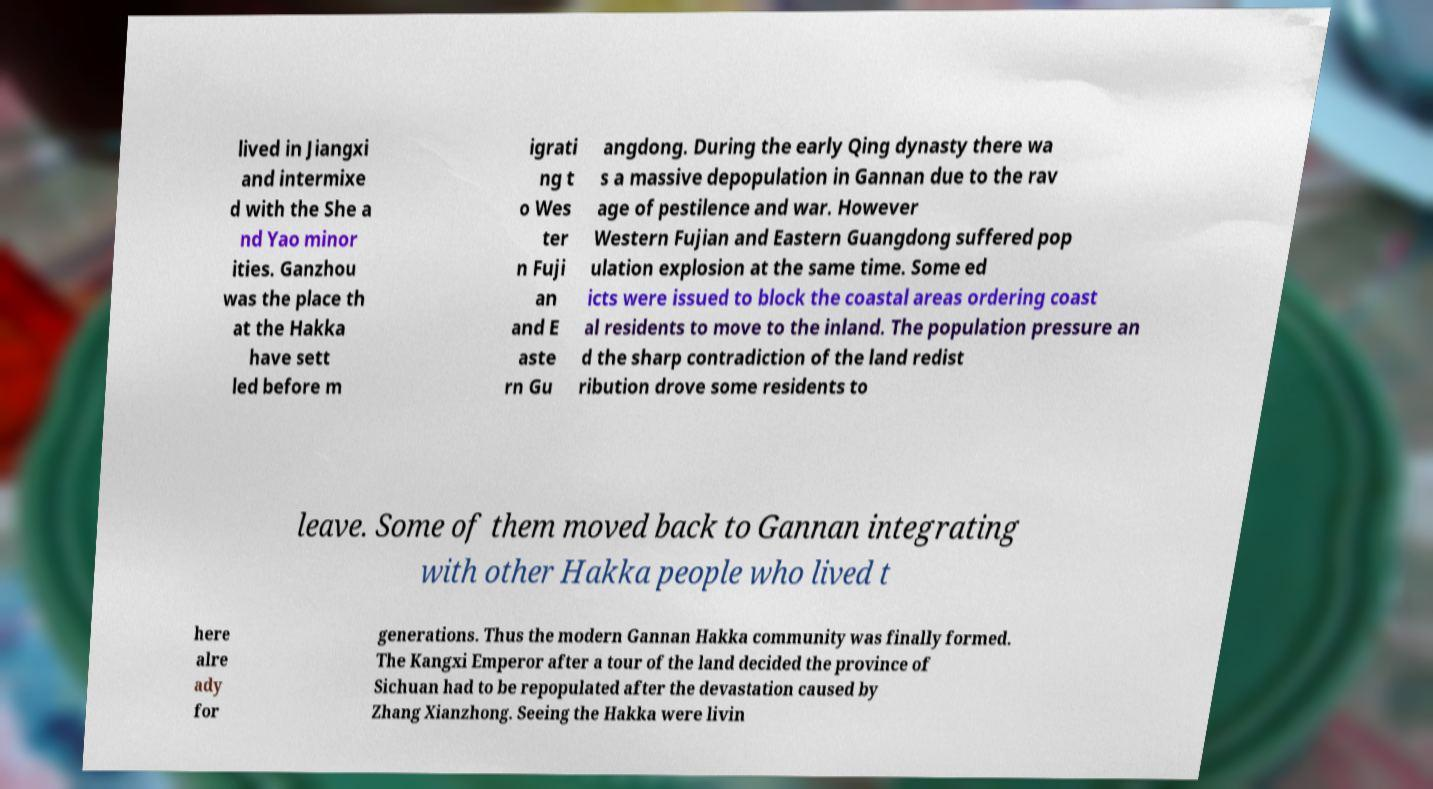Could you assist in decoding the text presented in this image and type it out clearly? lived in Jiangxi and intermixe d with the She a nd Yao minor ities. Ganzhou was the place th at the Hakka have sett led before m igrati ng t o Wes ter n Fuji an and E aste rn Gu angdong. During the early Qing dynasty there wa s a massive depopulation in Gannan due to the rav age of pestilence and war. However Western Fujian and Eastern Guangdong suffered pop ulation explosion at the same time. Some ed icts were issued to block the coastal areas ordering coast al residents to move to the inland. The population pressure an d the sharp contradiction of the land redist ribution drove some residents to leave. Some of them moved back to Gannan integrating with other Hakka people who lived t here alre ady for generations. Thus the modern Gannan Hakka community was finally formed. The Kangxi Emperor after a tour of the land decided the province of Sichuan had to be repopulated after the devastation caused by Zhang Xianzhong. Seeing the Hakka were livin 